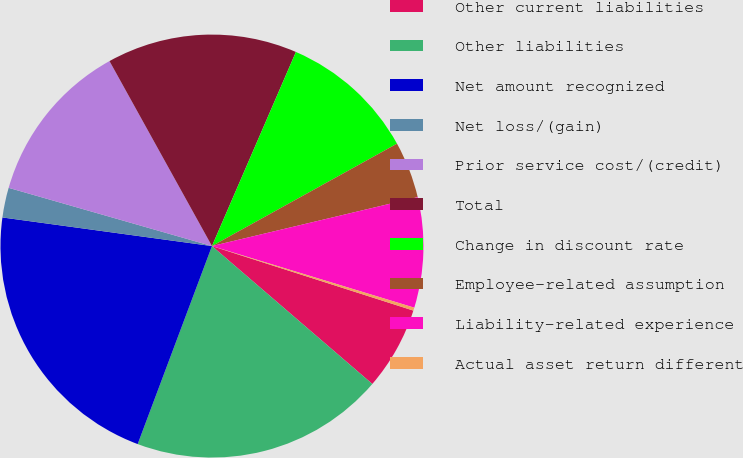<chart> <loc_0><loc_0><loc_500><loc_500><pie_chart><fcel>Other current liabilities<fcel>Other liabilities<fcel>Net amount recognized<fcel>Net loss/(gain)<fcel>Prior service cost/(credit)<fcel>Total<fcel>Change in discount rate<fcel>Employee-related assumption<fcel>Liability-related experience<fcel>Actual asset return different<nl><fcel>6.37%<fcel>19.41%<fcel>21.45%<fcel>2.28%<fcel>12.51%<fcel>14.55%<fcel>10.46%<fcel>4.33%<fcel>8.42%<fcel>0.23%<nl></chart> 